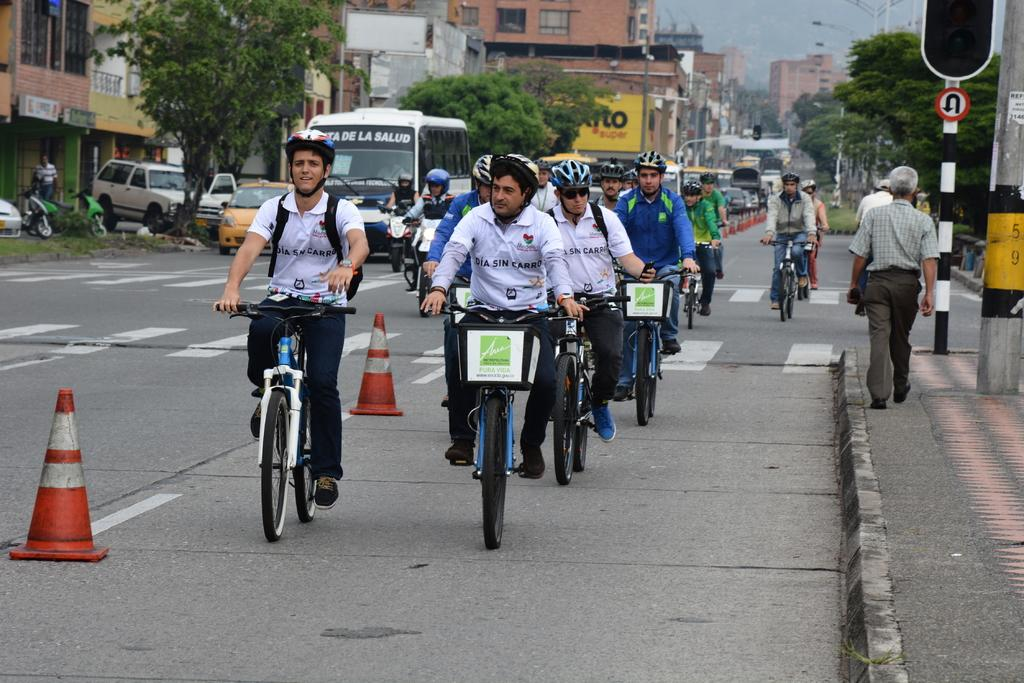How many persons can be seen in the image? There is a group of persons in the image. What are the persons in the image doing? The persons are riding bicycles. What type of natural vegetation is visible in the image? There are trees visible in the image. What type of man-made structures are visible in the image? There are buildings visible in the image. What type of transportation is visible in the image? There are vehicles visible in the image. What type of gate can be seen in the image? There is no gate present in the image. What type of nut is being used to tighten the bicycle wheels in the image? There is no nut visible in the image, nor is there any indication that the bicycle wheels are being tightened. 